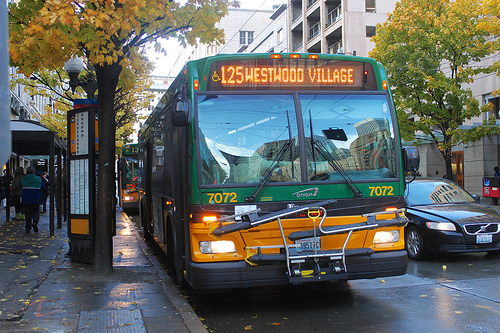What is the color of the vehicle that looks dry? The dry vehicle prominently visible in the image is a bus colored in deep black. 